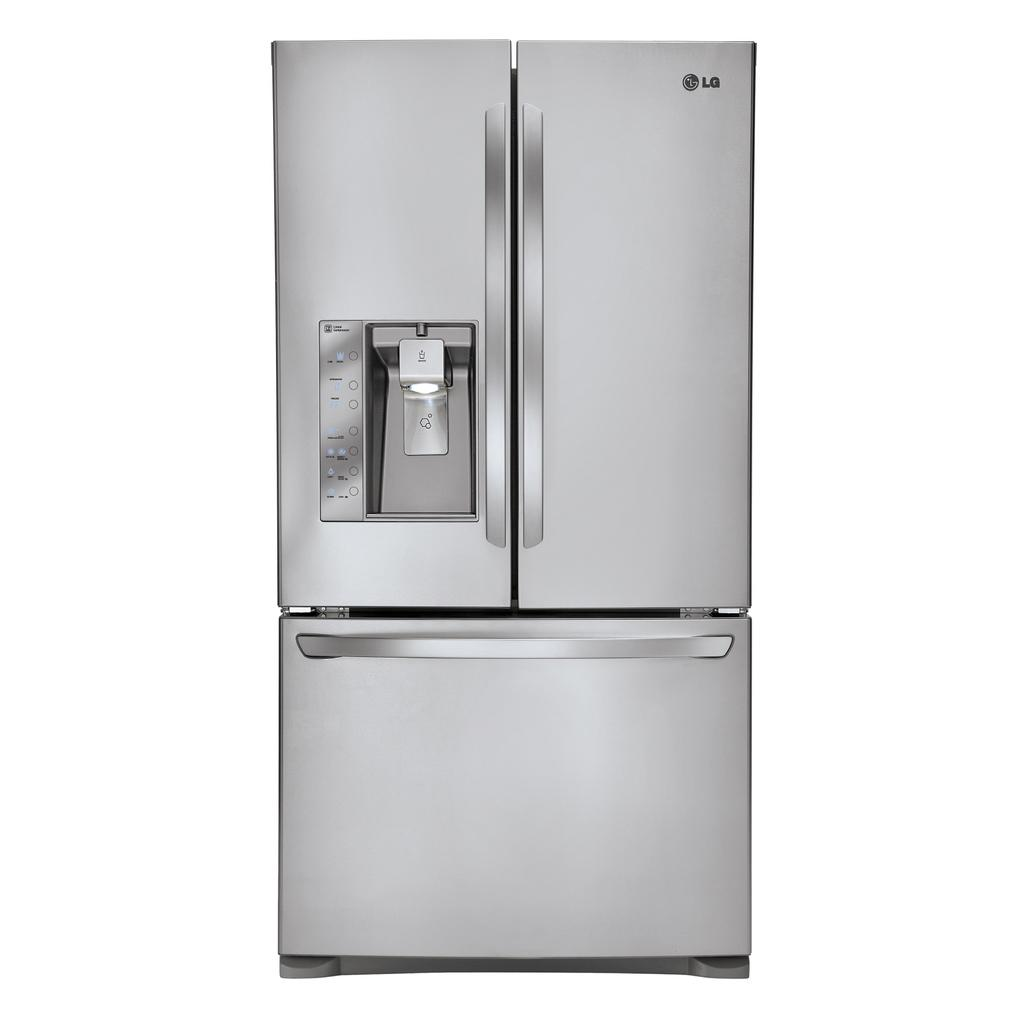<image>
Present a compact description of the photo's key features. LG fridge that is brand new with a ice freezer on the left 